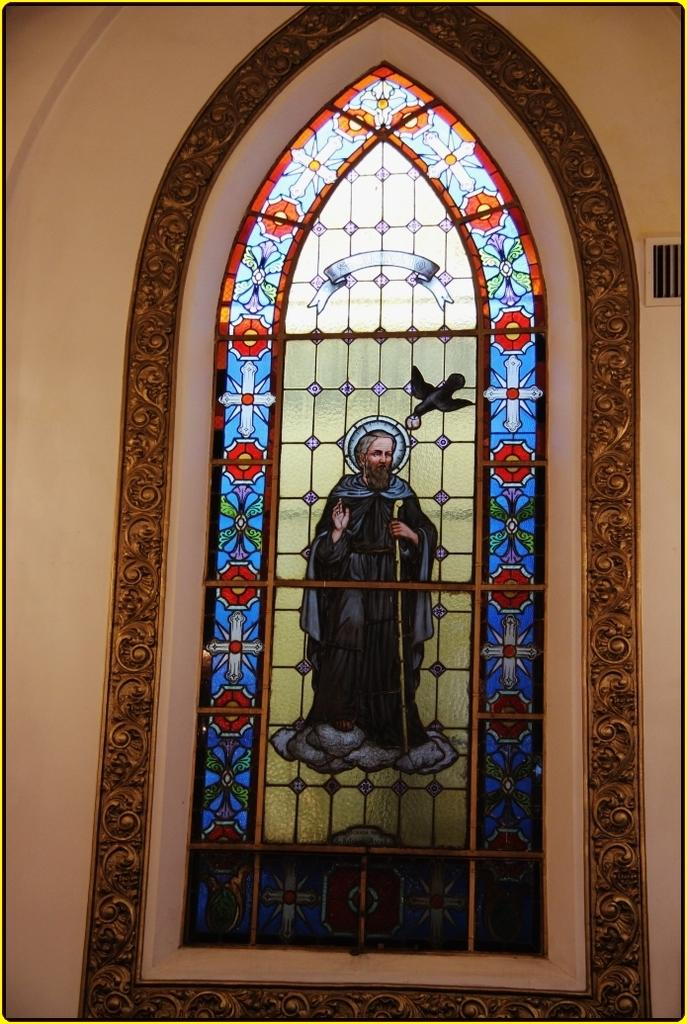What is depicted on the stained glass in the image? There is an image of Jesus Christ on the stained glass. What color is the wall in the image? There is a cream-colored wall in the image. How many cows can be seen grazing in the alley behind the wall in the image? There are no cows or alley present in the image; it features a stained glass with an image of Jesus Christ and a cream-colored wall. 